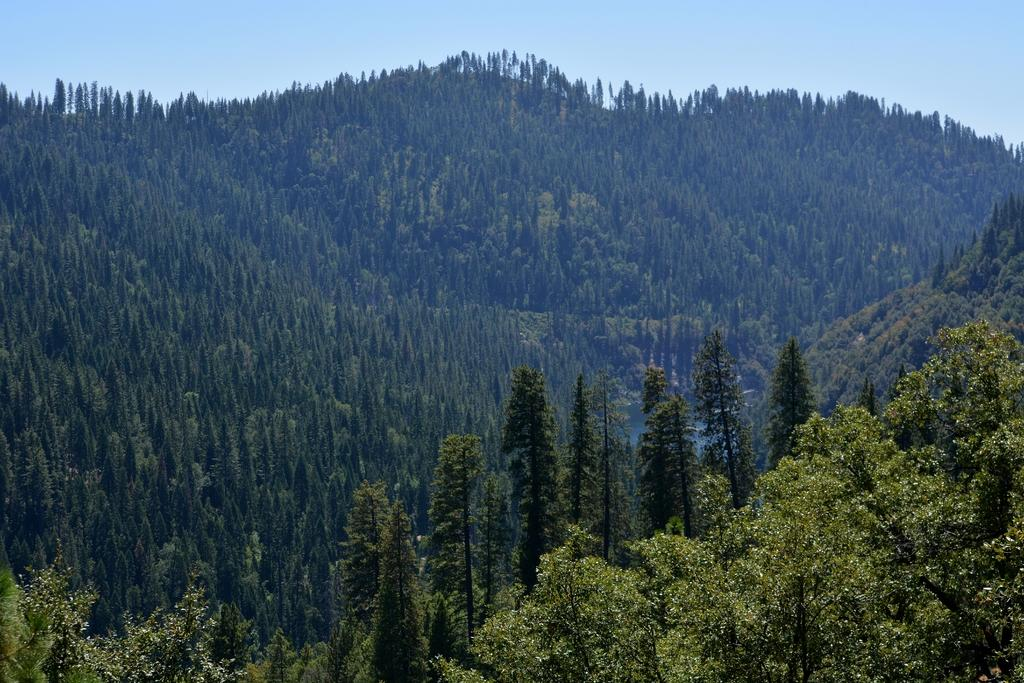What is located in the foreground of the image? There are trees in the foreground of the image. Where are the trees situated? The trees are on mountains. What is visible at the top of the image? The sky is visible at the top of the image. What type of vacation is the grandfather planning in the image? There is no information about a vacation or a grandfather in the image, so it cannot be determined from the image. 